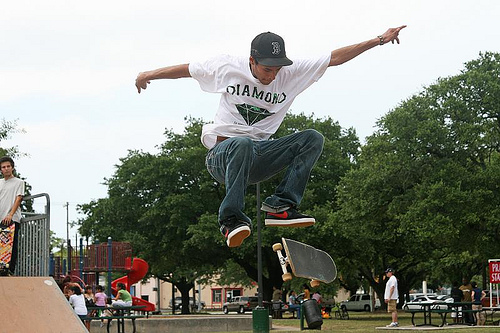<image>
Is the man on the skateboard? No. The man is not positioned on the skateboard. They may be near each other, but the man is not supported by or resting on top of the skateboard. 